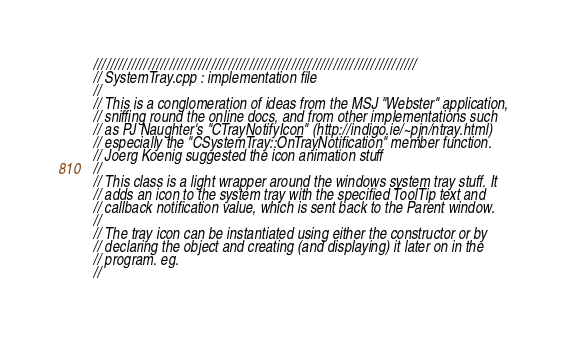<code> <loc_0><loc_0><loc_500><loc_500><_C++_>/////////////////////////////////////////////////////////////////////////////
// SystemTray.cpp : implementation file
//
// This is a conglomeration of ideas from the MSJ "Webster" application,
// sniffing round the online docs, and from other implementations such
// as PJ Naughter's "CTrayNotifyIcon" (http://indigo.ie/~pjn/ntray.html)
// especially the "CSystemTray::OnTrayNotification" member function.
// Joerg Koenig suggested the icon animation stuff
//
// This class is a light wrapper around the windows system tray stuff. It
// adds an icon to the system tray with the specified ToolTip text and 
// callback notification value, which is sent back to the Parent window.
//
// The tray icon can be instantiated using either the constructor or by
// declaring the object and creating (and displaying) it later on in the
// program. eg.
//</code> 